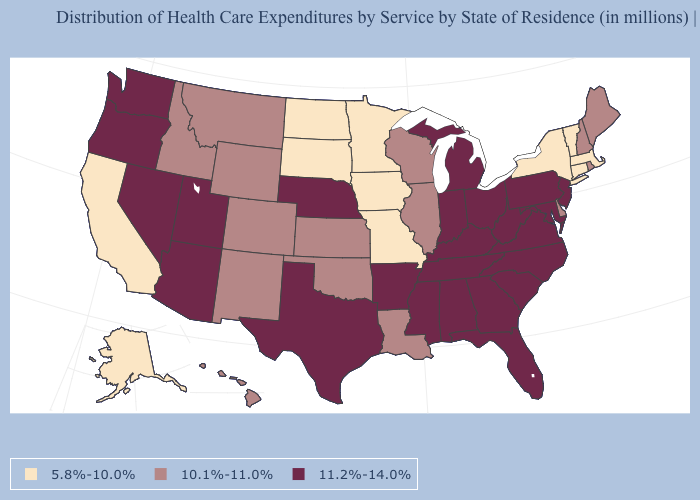Does the first symbol in the legend represent the smallest category?
Quick response, please. Yes. Name the states that have a value in the range 11.2%-14.0%?
Short answer required. Alabama, Arizona, Arkansas, Florida, Georgia, Indiana, Kentucky, Maryland, Michigan, Mississippi, Nebraska, Nevada, New Jersey, North Carolina, Ohio, Oregon, Pennsylvania, South Carolina, Tennessee, Texas, Utah, Virginia, Washington, West Virginia. Is the legend a continuous bar?
Short answer required. No. What is the value of Virginia?
Answer briefly. 11.2%-14.0%. Does Colorado have the lowest value in the West?
Give a very brief answer. No. Does Arizona have a higher value than Georgia?
Keep it brief. No. Name the states that have a value in the range 11.2%-14.0%?
Answer briefly. Alabama, Arizona, Arkansas, Florida, Georgia, Indiana, Kentucky, Maryland, Michigan, Mississippi, Nebraska, Nevada, New Jersey, North Carolina, Ohio, Oregon, Pennsylvania, South Carolina, Tennessee, Texas, Utah, Virginia, Washington, West Virginia. Name the states that have a value in the range 10.1%-11.0%?
Short answer required. Colorado, Delaware, Hawaii, Idaho, Illinois, Kansas, Louisiana, Maine, Montana, New Hampshire, New Mexico, Oklahoma, Rhode Island, Wisconsin, Wyoming. Does the map have missing data?
Be succinct. No. Does Tennessee have the lowest value in the USA?
Concise answer only. No. Name the states that have a value in the range 5.8%-10.0%?
Short answer required. Alaska, California, Connecticut, Iowa, Massachusetts, Minnesota, Missouri, New York, North Dakota, South Dakota, Vermont. What is the value of Missouri?
Give a very brief answer. 5.8%-10.0%. What is the value of Wyoming?
Be succinct. 10.1%-11.0%. Name the states that have a value in the range 5.8%-10.0%?
Short answer required. Alaska, California, Connecticut, Iowa, Massachusetts, Minnesota, Missouri, New York, North Dakota, South Dakota, Vermont. Among the states that border Connecticut , which have the lowest value?
Be succinct. Massachusetts, New York. 